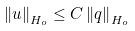<formula> <loc_0><loc_0><loc_500><loc_500>\left \| u \right \| _ { H _ { o } } \leq C \left \| q \right \| _ { H _ { o } }</formula> 